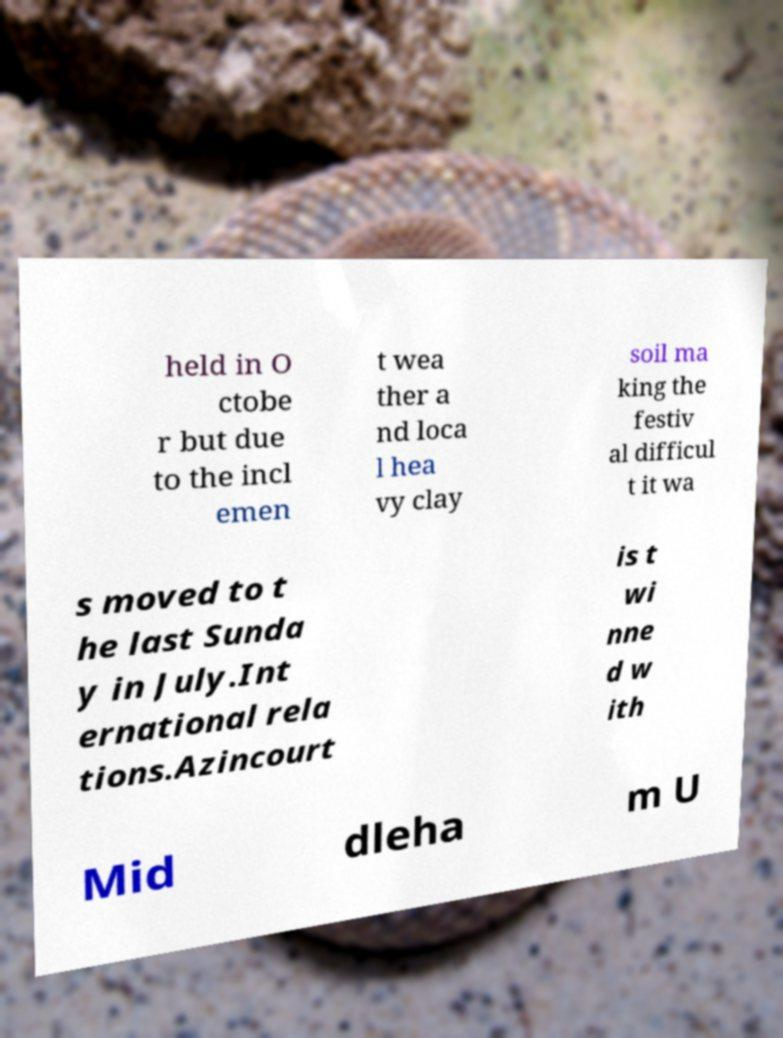Please identify and transcribe the text found in this image. held in O ctobe r but due to the incl emen t wea ther a nd loca l hea vy clay soil ma king the festiv al difficul t it wa s moved to t he last Sunda y in July.Int ernational rela tions.Azincourt is t wi nne d w ith Mid dleha m U 